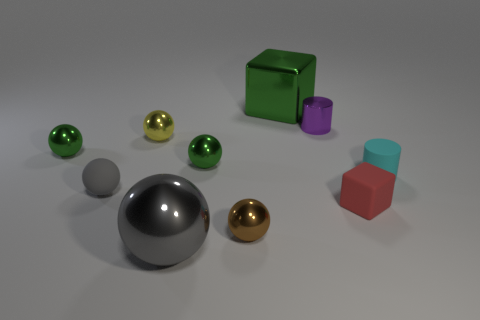Subtract 3 spheres. How many spheres are left? 3 Subtract all brown spheres. How many spheres are left? 5 Subtract all matte spheres. How many spheres are left? 5 Subtract all cyan spheres. Subtract all green cylinders. How many spheres are left? 6 Subtract all cylinders. How many objects are left? 8 Add 6 gray metal blocks. How many gray metal blocks exist? 6 Subtract 1 cyan cylinders. How many objects are left? 9 Subtract all small yellow shiny spheres. Subtract all cylinders. How many objects are left? 7 Add 7 large green shiny objects. How many large green shiny objects are left? 8 